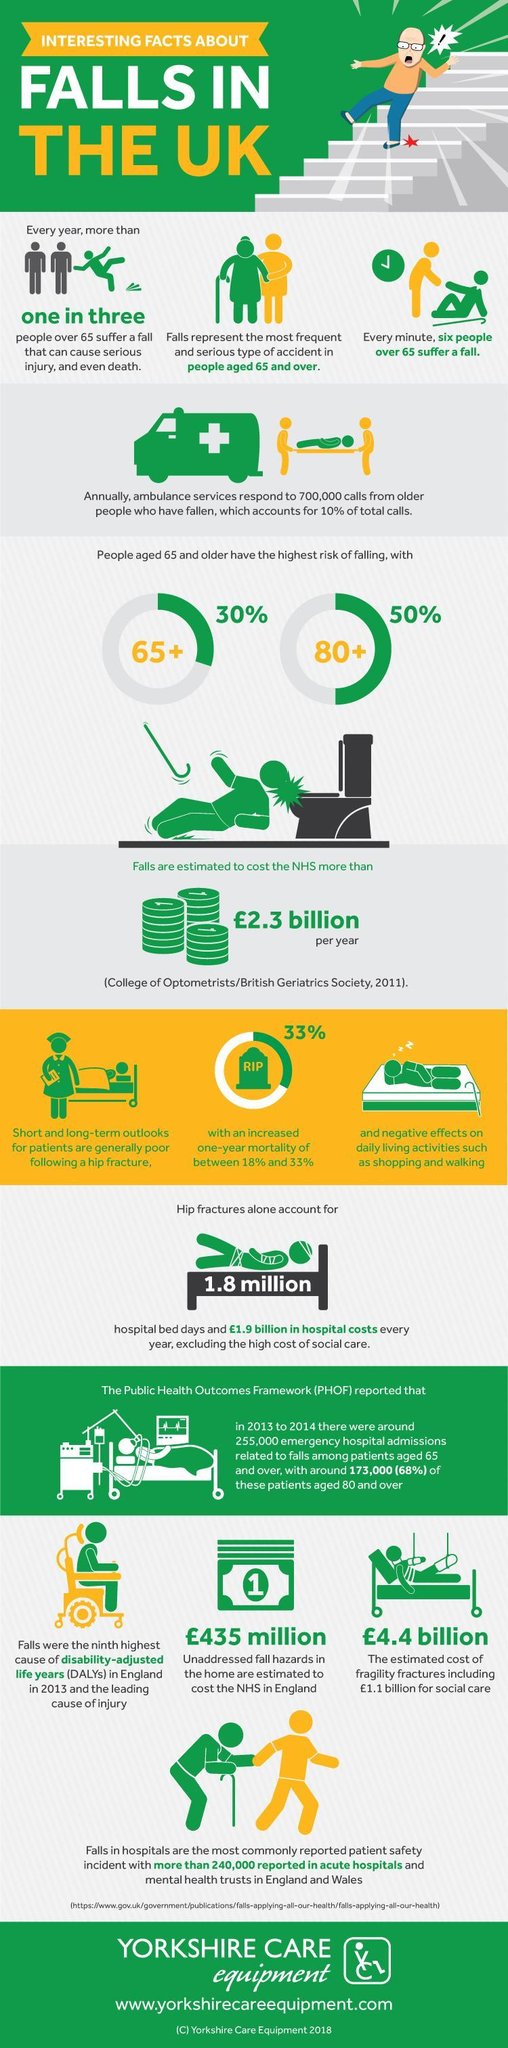How much is chance of senior citizens above 65 in UK to fall in a year?
Answer the question with a short phrase. 30% What is the number of senior citizens in UK do not falling in every minute? 5 How much is chance of senior citizens above 80 in UK to fall in a year? 50% What percentage of calls received by ambulance service is not calls related to falls? 90 What is the inverse of chance of senior citizens above 65 in UK to fall in a year? 70 What is the number of patients admitted in hospital due to falls and aged less than 80? 82,000 